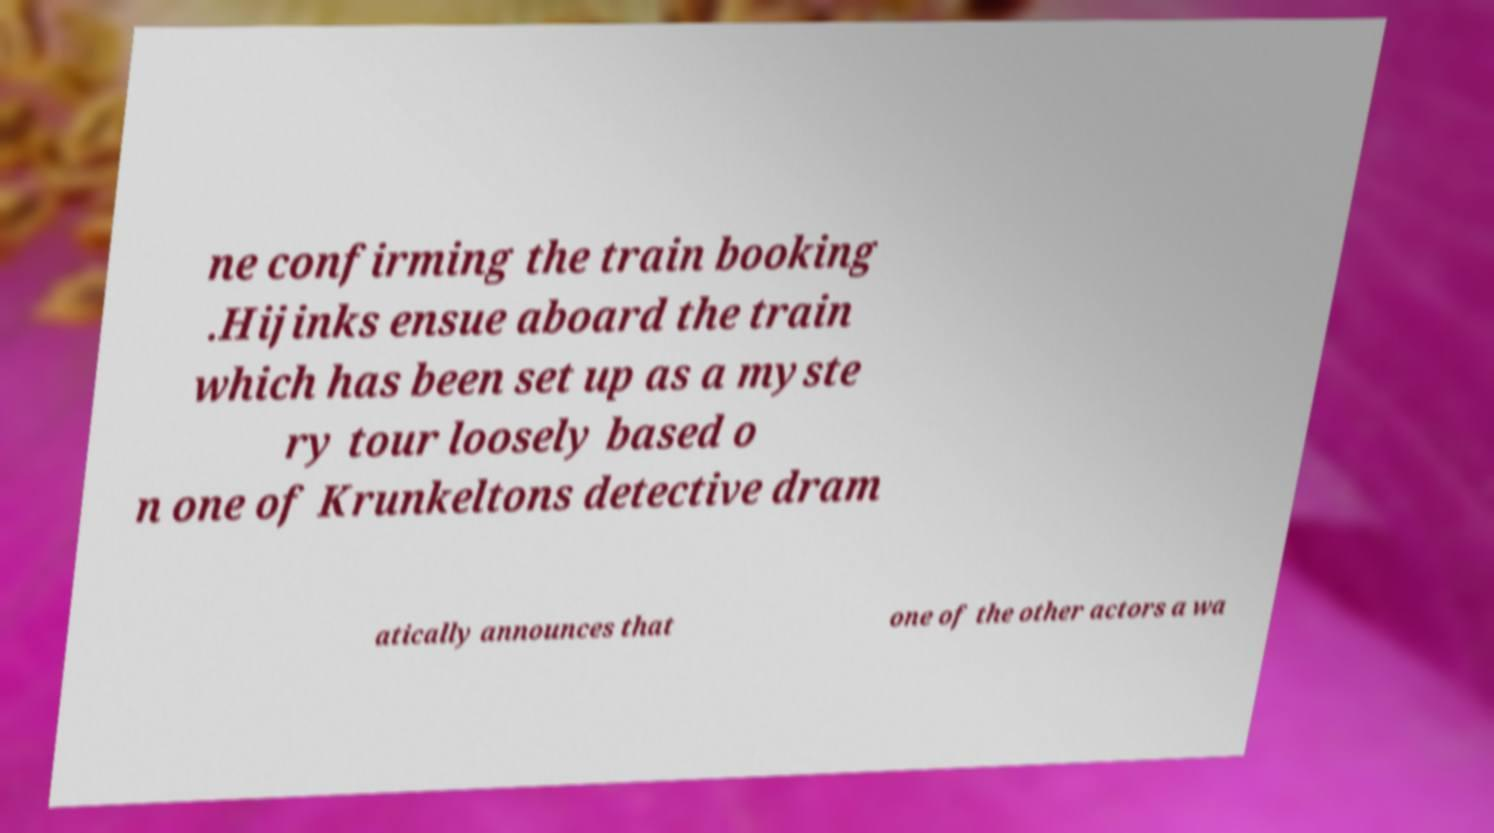What messages or text are displayed in this image? I need them in a readable, typed format. ne confirming the train booking .Hijinks ensue aboard the train which has been set up as a myste ry tour loosely based o n one of Krunkeltons detective dram atically announces that one of the other actors a wa 